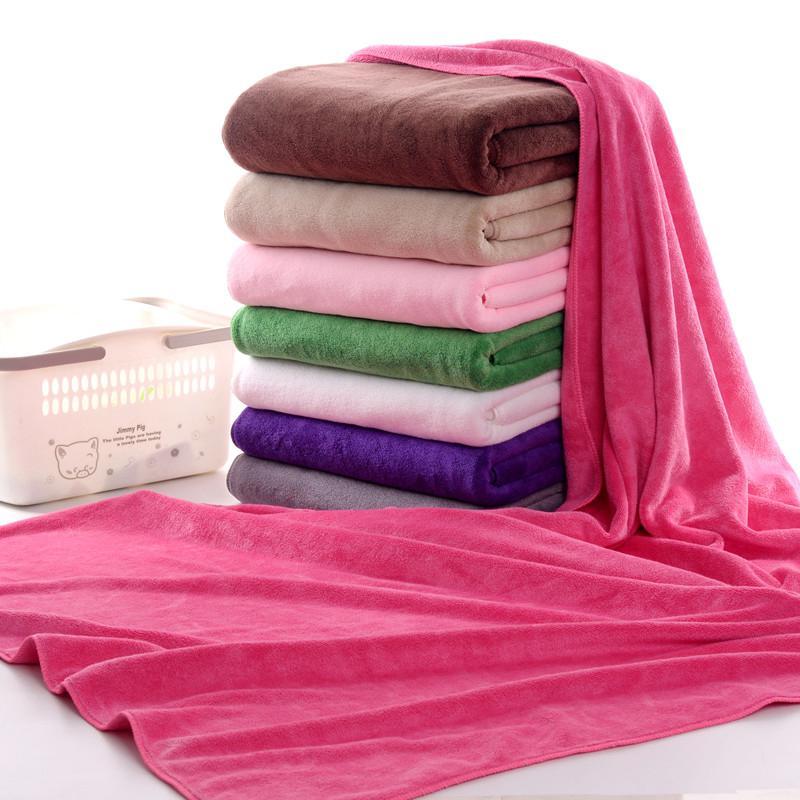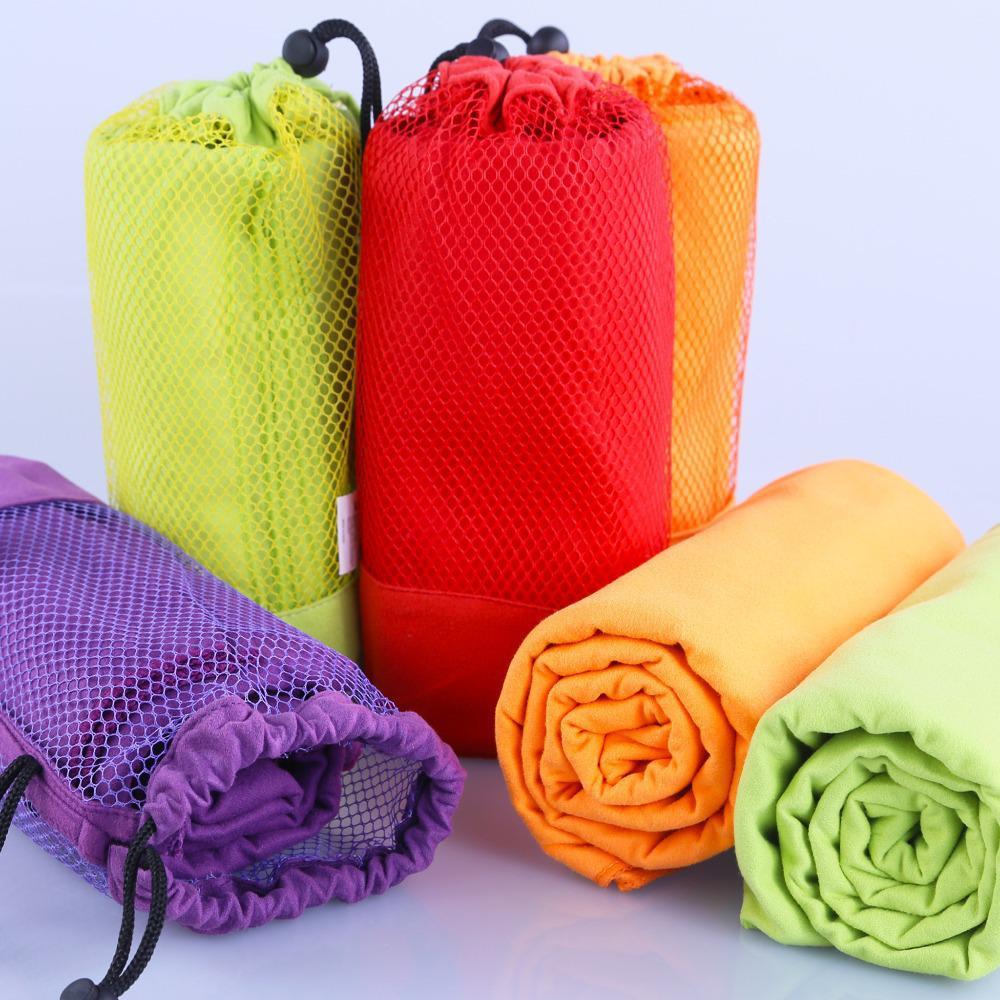The first image is the image on the left, the second image is the image on the right. Analyze the images presented: Is the assertion "In the image on the left the there is an orange towel at the top of a stack of towels." valid? Answer yes or no. No. The first image is the image on the left, the second image is the image on the right. Evaluate the accuracy of this statement regarding the images: "In one image, a pink towel is draped over and around a single stack of seven or fewer folded towels in various colors.". Is it true? Answer yes or no. Yes. 